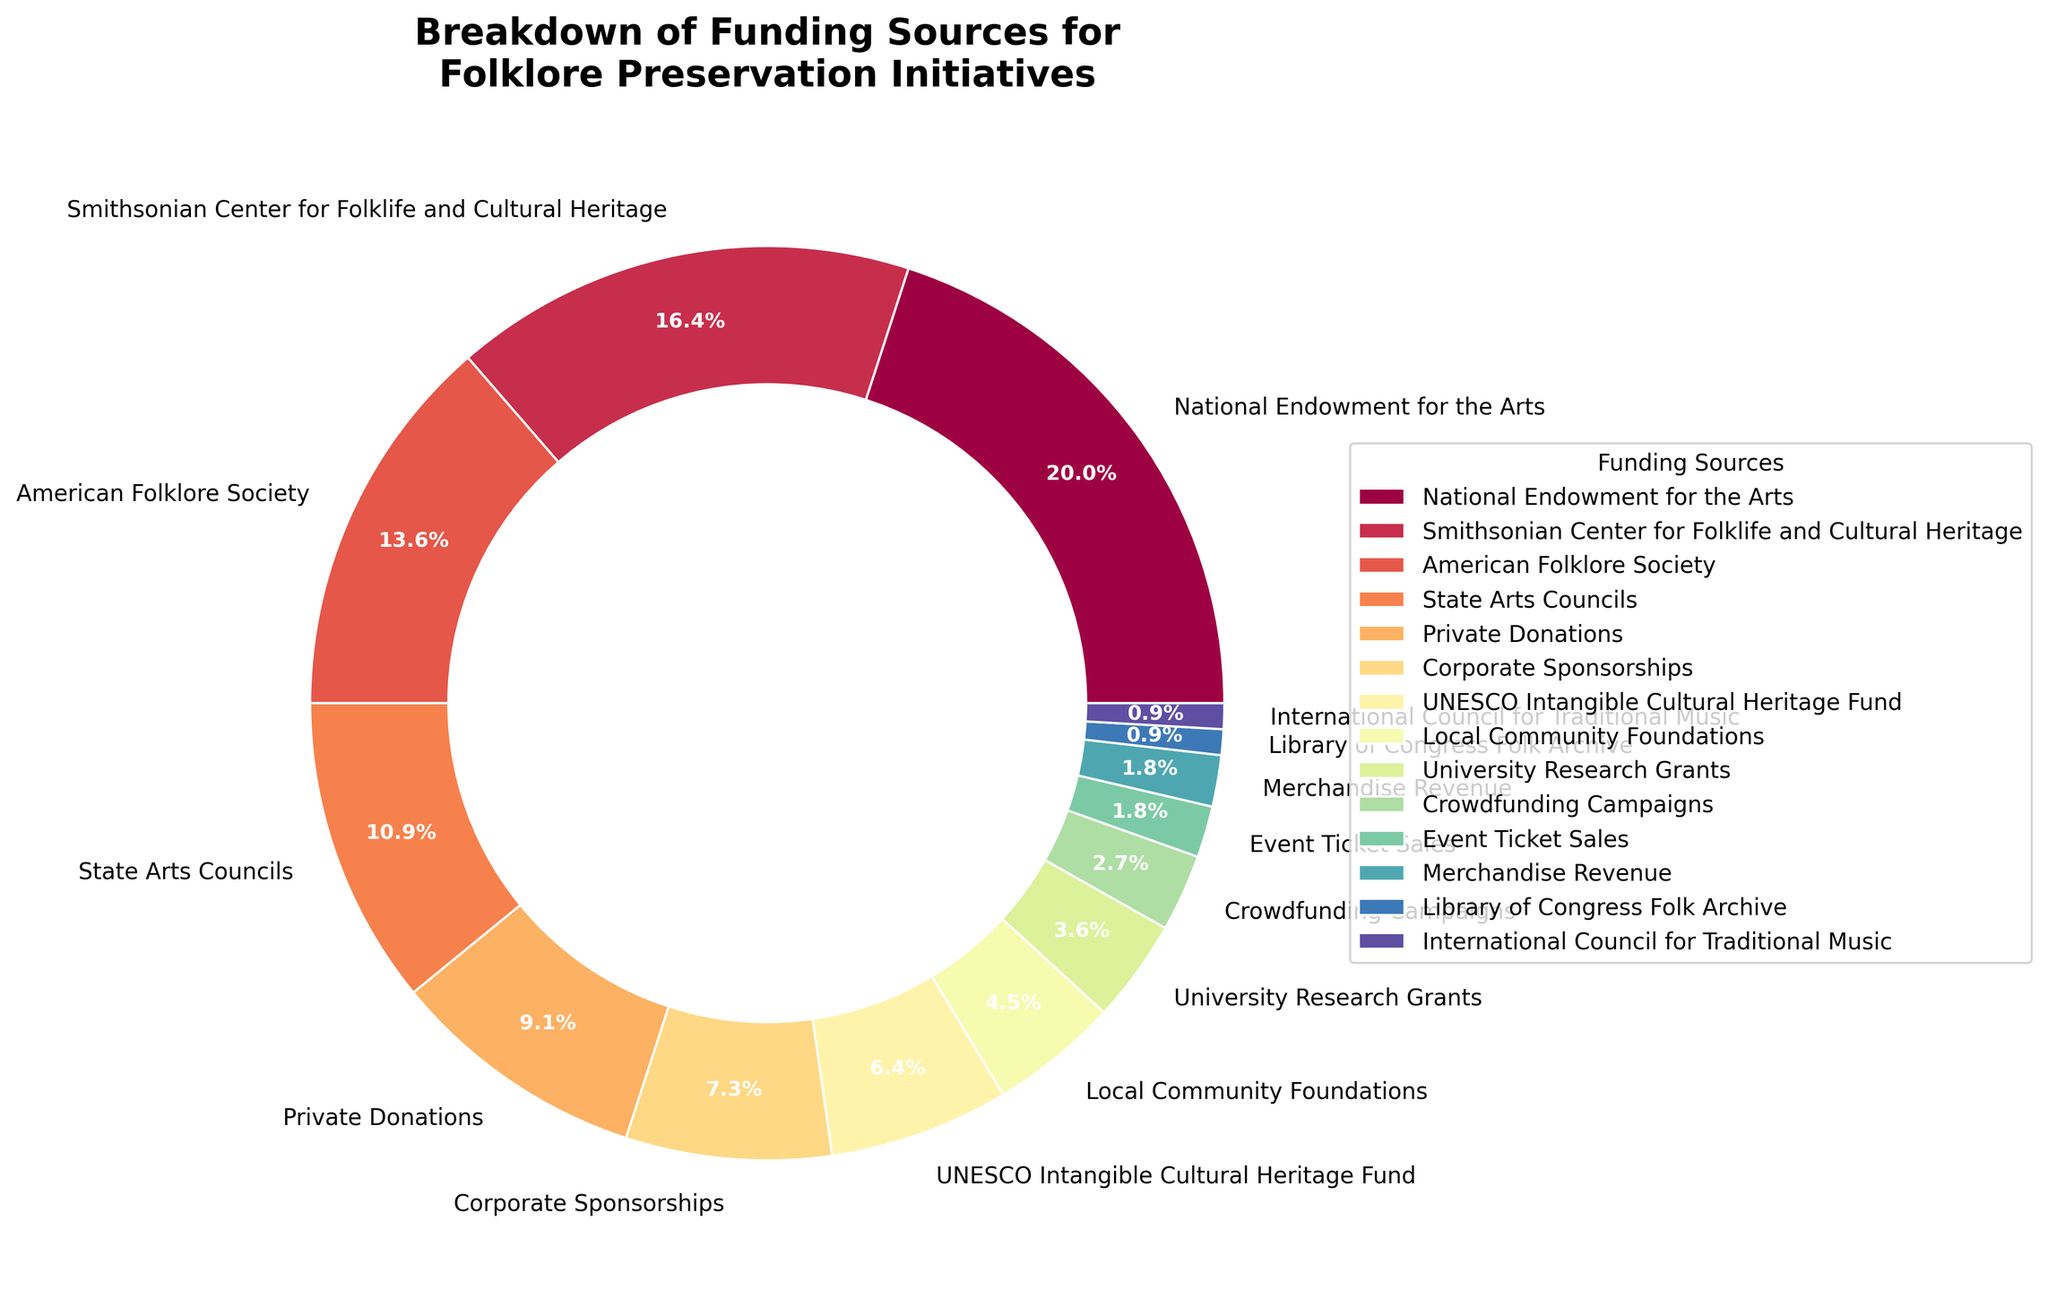What's the largest funding source for folklore preservation initiatives? The largest segment on the pie chart represents the National Endowment for the Arts, which covers 22% of the total funding.
Answer: National Endowment for the Arts Which funding sources contribute equally to the initiatives? Event Ticket Sales and Merchandise Revenue each contribute 2% to the total funding.
Answer: Event Ticket Sales, Merchandise Revenue What's the total percentage contribution of the three largest funding sources? Summing up the percentages of the National Endowment for the Arts (22%), Smithsonian Center for Folklife and Cultural Heritage (18%), and American Folklore Society (15%) gives 22 + 18 + 15 = 55%.
Answer: 55% Is private funding (Private Donations + Corporate Sponsorships) greater than the funding provided by the American Folklore Society? Summing the contributions from Private Donations (10%) and Corporate Sponsorships (8%) gives 10 + 8 = 18%, which is equal to the 18% contribution of the American Folklore Society.
Answer: No, it is equal Among the top four contributors, which one provides the least funding? The top four contributors are the National Endowment for the Arts (22%), Smithsonian Center for Folklife and Cultural Heritage (18%), American Folklore Society (15%), and State Arts Councils (12%). The State Arts Councils provide the least funding.
Answer: State Arts Councils What is the combined contribution from international organizations like UNESCO and the International Council for Traditional Music? Summing up the percentages provided by UNESCO Intangible Cultural Heritage Fund (7%) and International Council for Traditional Music (1%) gives 7 + 1 = 8%.
Answer: 8% Which category contributes the smallest percentage to the folklife preservation initiatives, and how much is it? The smallest slices from the pie chart are Library of Congress Folk Archive and International Council for Traditional Music, each contributing 1%.
Answer: Library of Congress Folk Archive and International Council for Traditional Music, 1% each How much more does the Smithsonian Center for Folklife and Cultural Heritage contribute compared to Corporate Sponsorships? The Smithsonian Center for Folklife and Cultural Heritage contributes 18%, while Corporate Sponsorships contribute 8%. The difference is 18 - 8 = 10%.
Answer: 10% Does the contribution from University Research Grants exceed Crowdfunding Campaigns and Local Community Foundations combined? University Research Grants contribute 4%. Crowdfunding Campaigns contribute 3%, and Local Community Foundations contribute 5%. Combined, they contribute 3 + 5 = 8%, which is greater than 4%.
Answer: No Which funding source occupies the most prominent color on the pie chart, and what percentage is it responsible for? The largest segment, represented by the National Endowment for the Arts, occupies the most prominent color and covers 22%.
Answer: National Endowment for the Arts, 22% 